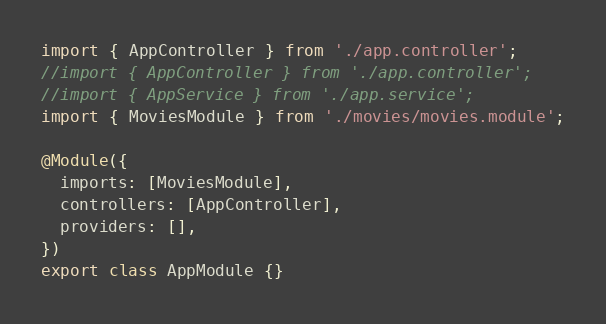<code> <loc_0><loc_0><loc_500><loc_500><_TypeScript_>import { AppController } from './app.controller';
//import { AppController } from './app.controller';
//import { AppService } from './app.service';
import { MoviesModule } from './movies/movies.module';

@Module({
  imports: [MoviesModule],
  controllers: [AppController],
  providers: [],
})
export class AppModule {}
</code> 